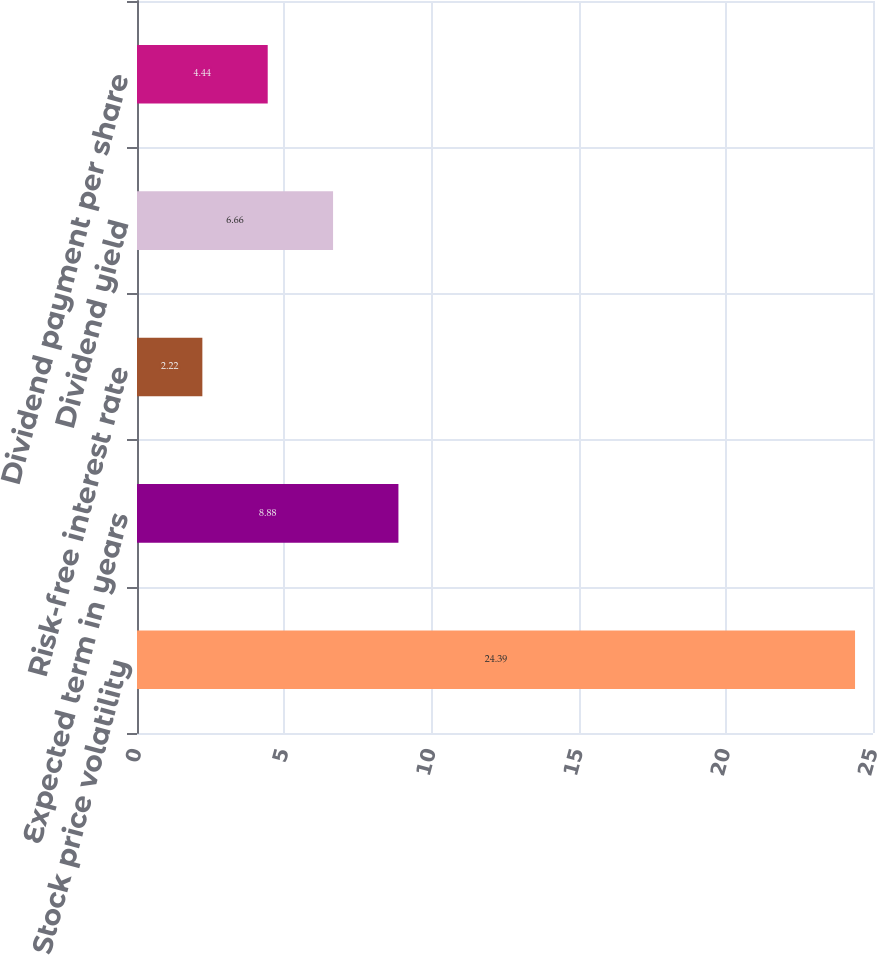Convert chart. <chart><loc_0><loc_0><loc_500><loc_500><bar_chart><fcel>Stock price volatility<fcel>Expected term in years<fcel>Risk-free interest rate<fcel>Dividend yield<fcel>Dividend payment per share<nl><fcel>24.39<fcel>8.88<fcel>2.22<fcel>6.66<fcel>4.44<nl></chart> 